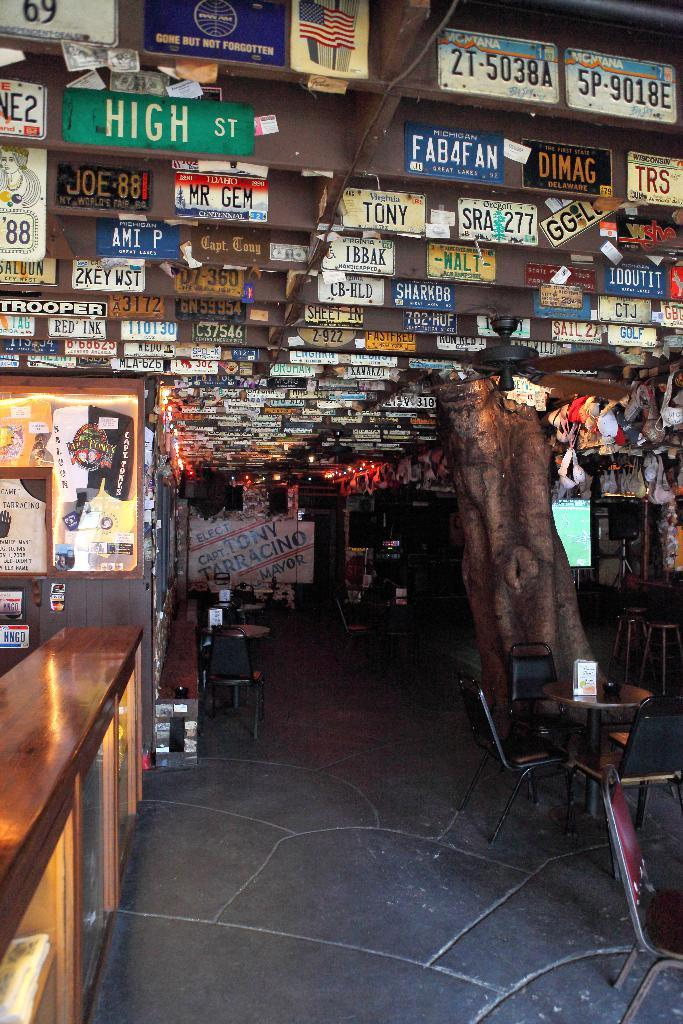<image>
Create a compact narrative representing the image presented. a sign above the store that says High street on it 